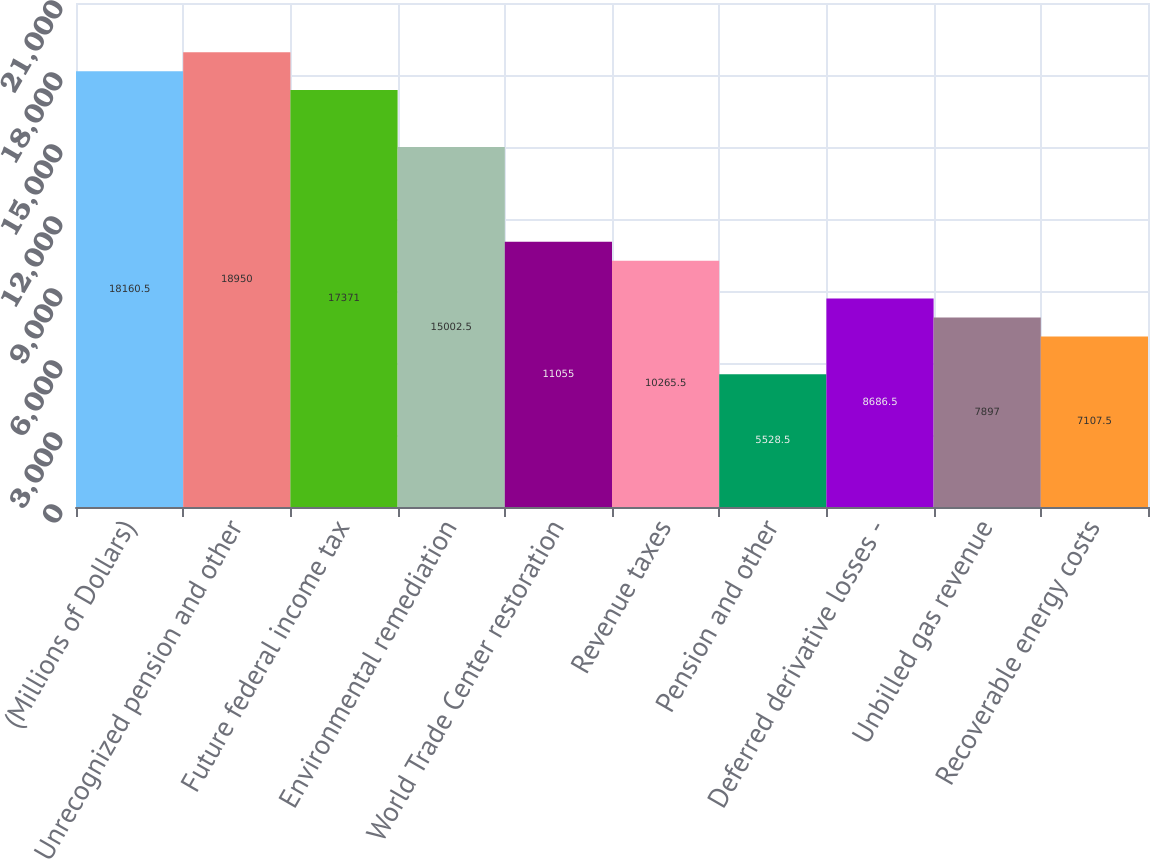<chart> <loc_0><loc_0><loc_500><loc_500><bar_chart><fcel>(Millions of Dollars)<fcel>Unrecognized pension and other<fcel>Future federal income tax<fcel>Environmental remediation<fcel>World Trade Center restoration<fcel>Revenue taxes<fcel>Pension and other<fcel>Deferred derivative losses -<fcel>Unbilled gas revenue<fcel>Recoverable energy costs<nl><fcel>18160.5<fcel>18950<fcel>17371<fcel>15002.5<fcel>11055<fcel>10265.5<fcel>5528.5<fcel>8686.5<fcel>7897<fcel>7107.5<nl></chart> 